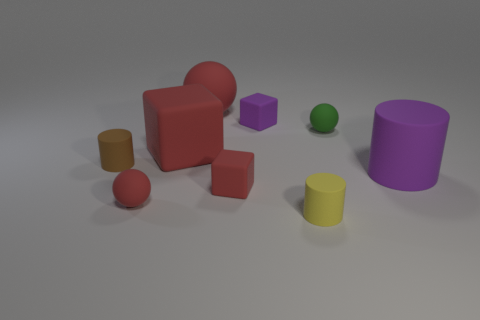Are there any large purple cylinders behind the rubber ball behind the small purple object?
Give a very brief answer. No. The other cylinder that is the same size as the yellow matte cylinder is what color?
Your response must be concise. Brown. How many objects are either cyan spheres or purple matte things?
Give a very brief answer. 2. What size is the cylinder on the right side of the tiny matte cylinder that is in front of the block in front of the tiny brown thing?
Keep it short and to the point. Large. What number of tiny matte blocks have the same color as the big matte cylinder?
Provide a short and direct response. 1. What number of gray cylinders are the same material as the small green thing?
Your answer should be compact. 0. How many objects are either small red metal cubes or balls that are in front of the green matte ball?
Give a very brief answer. 1. What is the color of the cylinder that is to the left of the red matte ball behind the cube in front of the large purple matte cylinder?
Your response must be concise. Brown. There is a purple thing that is to the left of the tiny yellow matte thing; how big is it?
Offer a very short reply. Small. How many large objects are either green rubber spheres or purple matte objects?
Provide a succinct answer. 1. 